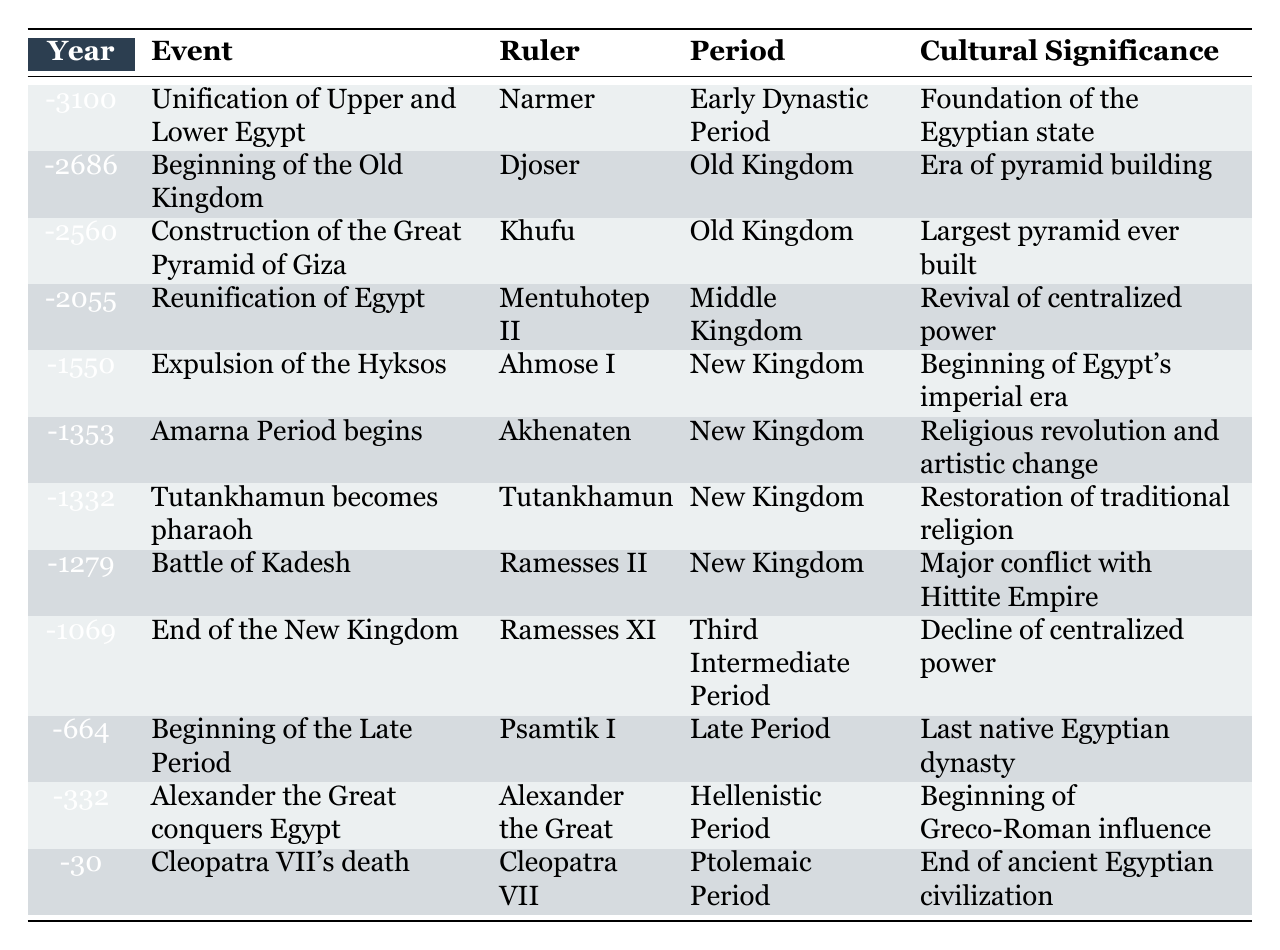What year did the construction of the Great Pyramid of Giza occur? According to the table, the construction of the Great Pyramid of Giza is listed under the year -2560.
Answer: -2560 Who was the ruler during the beginning of the Old Kingdom? The table shows that the ruler during the beginning of the Old Kingdom, which occurred in -2686, was Djoser.
Answer: Djoser What event marks the end of the New Kingdom? The last entry under the New Kingdom in the table is the end of the New Kingdom, which is recorded as occurring in -1069 with Ramesses XI.
Answer: End of the New Kingdom How many events are listed in the Old Kingdom period? By examining the table, there are three events recorded under the Old Kingdom: Beginning of the Old Kingdom, Construction of the Great Pyramid of Giza, and Tutankhamun becomes pharaoh.
Answer: 3 Is the Amarna Period associated with Akhenaten? The table indicates that the Amarna Period, beginning in -1353, is indeed associated with the ruler Akhenaten.
Answer: Yes What event occurred closest to the death of Cleopatra VII? By looking at the table, Cleopatra VII's death in -30 is the last event, making it the closest event listed.
Answer: Cleopatra VII's death Which ruler presided over the expulsion of the Hyksos? The table states that Ahmose I was the ruler during the event of the expulsion of the Hyksos in -1550.
Answer: Ahmose I Determine the total number of dynasties mentioned in the table. There are mentions of the Early Dynastic Period, Old Kingdom, Middle Kingdom, New Kingdom, Third Intermediate Period, Late Period, Hellenistic Period, and Ptolemaic Period, totaling 7 different periods (indicating many dynasties).
Answer: 7 What is the significance of the Battle of Kadesh? The table notes that the Battle of Kadesh, which occurred in -1279, is significant as a major conflict with the Hittite Empire.
Answer: Major conflict with Hittite Empire Was the Unification of Upper and Lower Egypt considered a significant event? The cultural significance for this event in -3100 indicates it is indeed considered a major moment as it is the foundation of the Egyptian state.
Answer: Yes Which period follows the Middle Kingdom? In the sequence of the table, the period following the Middle Kingdom is the New Kingdom, as indicated by the years listed.
Answer: New Kingdom 